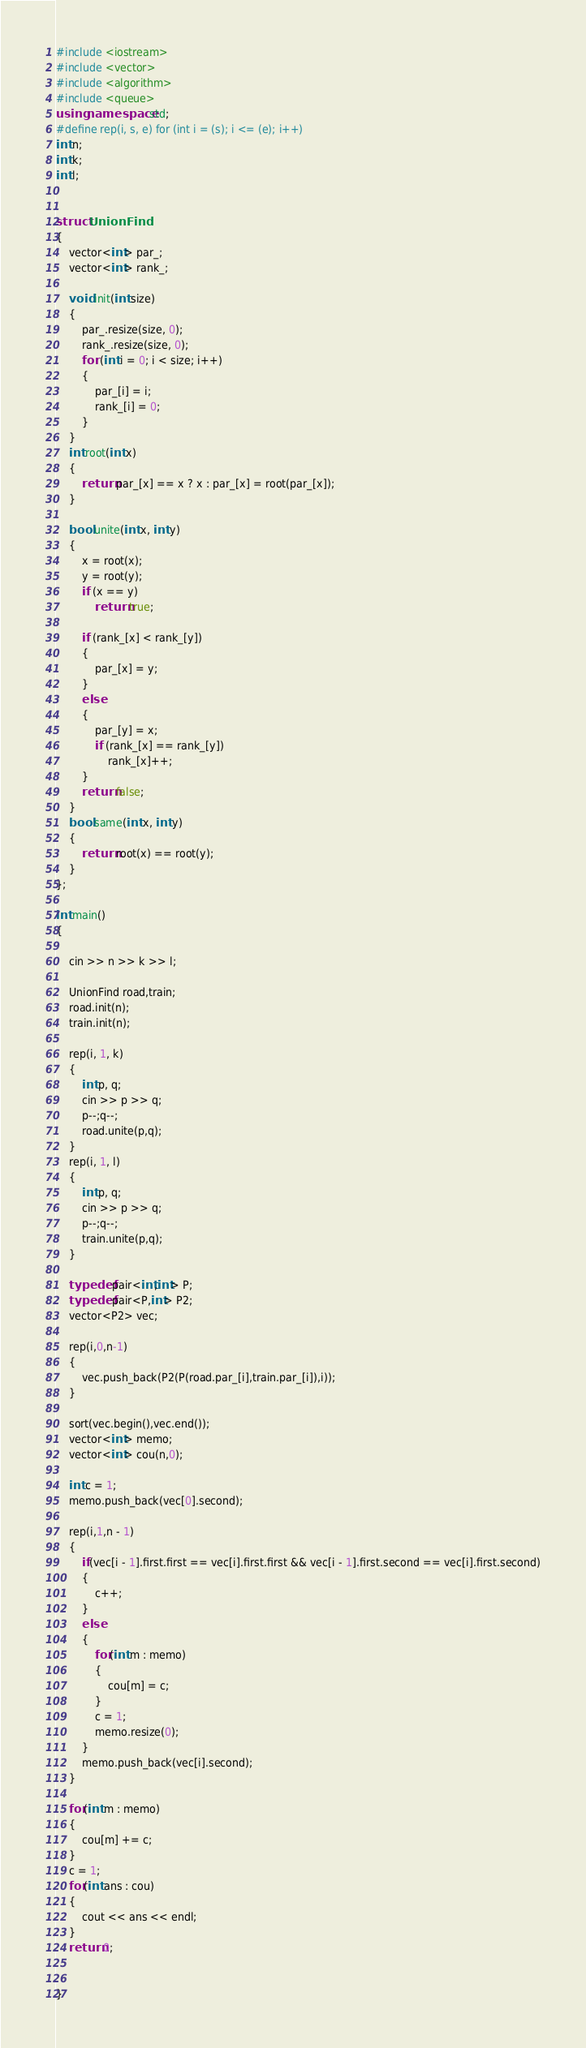Convert code to text. <code><loc_0><loc_0><loc_500><loc_500><_C++_>#include <iostream>
#include <vector>
#include <algorithm>
#include <queue>
using namespace std;
#define rep(i, s, e) for (int i = (s); i <= (e); i++)
int n;
int k;
int l;


struct UnionFind
{
	vector<int> par_;
	vector<int> rank_;

	void init(int size)
	{
		par_.resize(size, 0);
		rank_.resize(size, 0);
		for (int i = 0; i < size; i++)
		{
			par_[i] = i;
			rank_[i] = 0;
		}
	}
	int root(int x)
	{
		return par_[x] == x ? x : par_[x] = root(par_[x]);
	}

	bool unite(int x, int y)
	{
		x = root(x);
		y = root(y);
		if (x == y)
			return true;

		if (rank_[x] < rank_[y])
		{
			par_[x] = y;
		}
		else
		{
			par_[y] = x;
			if (rank_[x] == rank_[y])
				rank_[x]++;
		}
		return false;
	}
	bool same(int x, int y)
	{
		return root(x) == root(y);
	}
};

int main()
{

	cin >> n >> k >> l;

	UnionFind road,train;
	road.init(n);
	train.init(n);

	rep(i, 1, k)
	{
		int p, q;
		cin >> p >> q;
		p--;q--;
		road.unite(p,q);
	}
	rep(i, 1, l)
	{
		int p, q;
		cin >> p >> q;
		p--;q--;
		train.unite(p,q);
	}

	typedef pair<int,int> P;
	typedef pair<P,int> P2;
	vector<P2> vec;

	rep(i,0,n-1)
	{
		vec.push_back(P2(P(road.par_[i],train.par_[i]),i));
	}

	sort(vec.begin(),vec.end());
	vector<int> memo;
	vector<int> cou(n,0);

	int c = 1;
	memo.push_back(vec[0].second);

	rep(i,1,n - 1)
	{
		if(vec[i - 1].first.first == vec[i].first.first && vec[i - 1].first.second == vec[i].first.second)
		{
			c++;
		}
		else
		{
			for(int m : memo)
			{
				cou[m] = c;
			}
			c = 1;
			memo.resize(0);
		}
		memo.push_back(vec[i].second);
	}

	for(int m : memo)
	{
		cou[m] += c;
	}
	c = 1;
	for(int ans : cou)
	{
		cout << ans << endl;
	}
	return 0;


}
</code> 